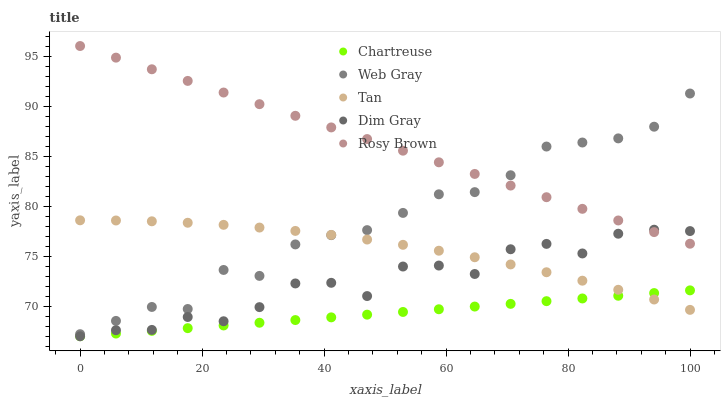Does Chartreuse have the minimum area under the curve?
Answer yes or no. Yes. Does Rosy Brown have the maximum area under the curve?
Answer yes or no. Yes. Does Web Gray have the minimum area under the curve?
Answer yes or no. No. Does Web Gray have the maximum area under the curve?
Answer yes or no. No. Is Rosy Brown the smoothest?
Answer yes or no. Yes. Is Dim Gray the roughest?
Answer yes or no. Yes. Is Web Gray the smoothest?
Answer yes or no. No. Is Web Gray the roughest?
Answer yes or no. No. Does Chartreuse have the lowest value?
Answer yes or no. Yes. Does Web Gray have the lowest value?
Answer yes or no. No. Does Rosy Brown have the highest value?
Answer yes or no. Yes. Does Web Gray have the highest value?
Answer yes or no. No. Is Tan less than Rosy Brown?
Answer yes or no. Yes. Is Web Gray greater than Dim Gray?
Answer yes or no. Yes. Does Dim Gray intersect Chartreuse?
Answer yes or no. Yes. Is Dim Gray less than Chartreuse?
Answer yes or no. No. Is Dim Gray greater than Chartreuse?
Answer yes or no. No. Does Tan intersect Rosy Brown?
Answer yes or no. No. 